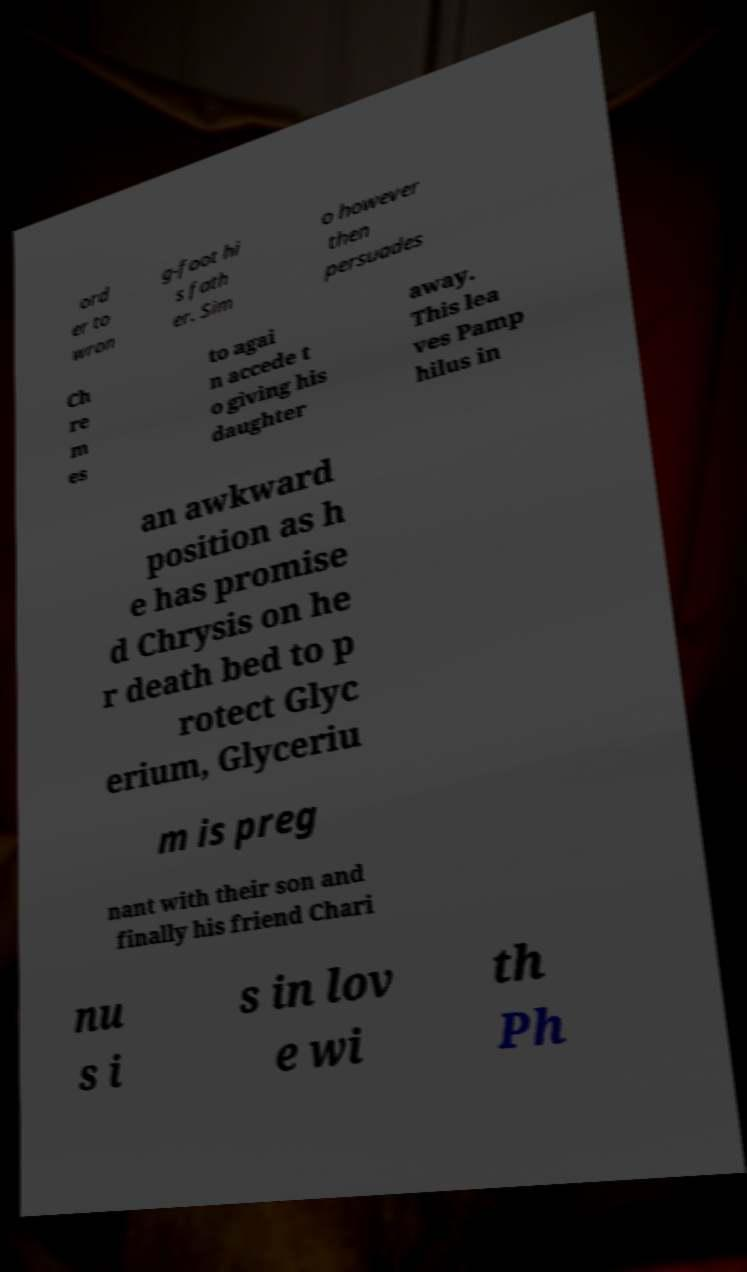There's text embedded in this image that I need extracted. Can you transcribe it verbatim? ord er to wron g-foot hi s fath er. Sim o however then persuades Ch re m es to agai n accede t o giving his daughter away. This lea ves Pamp hilus in an awkward position as h e has promise d Chrysis on he r death bed to p rotect Glyc erium, Glyceriu m is preg nant with their son and finally his friend Chari nu s i s in lov e wi th Ph 